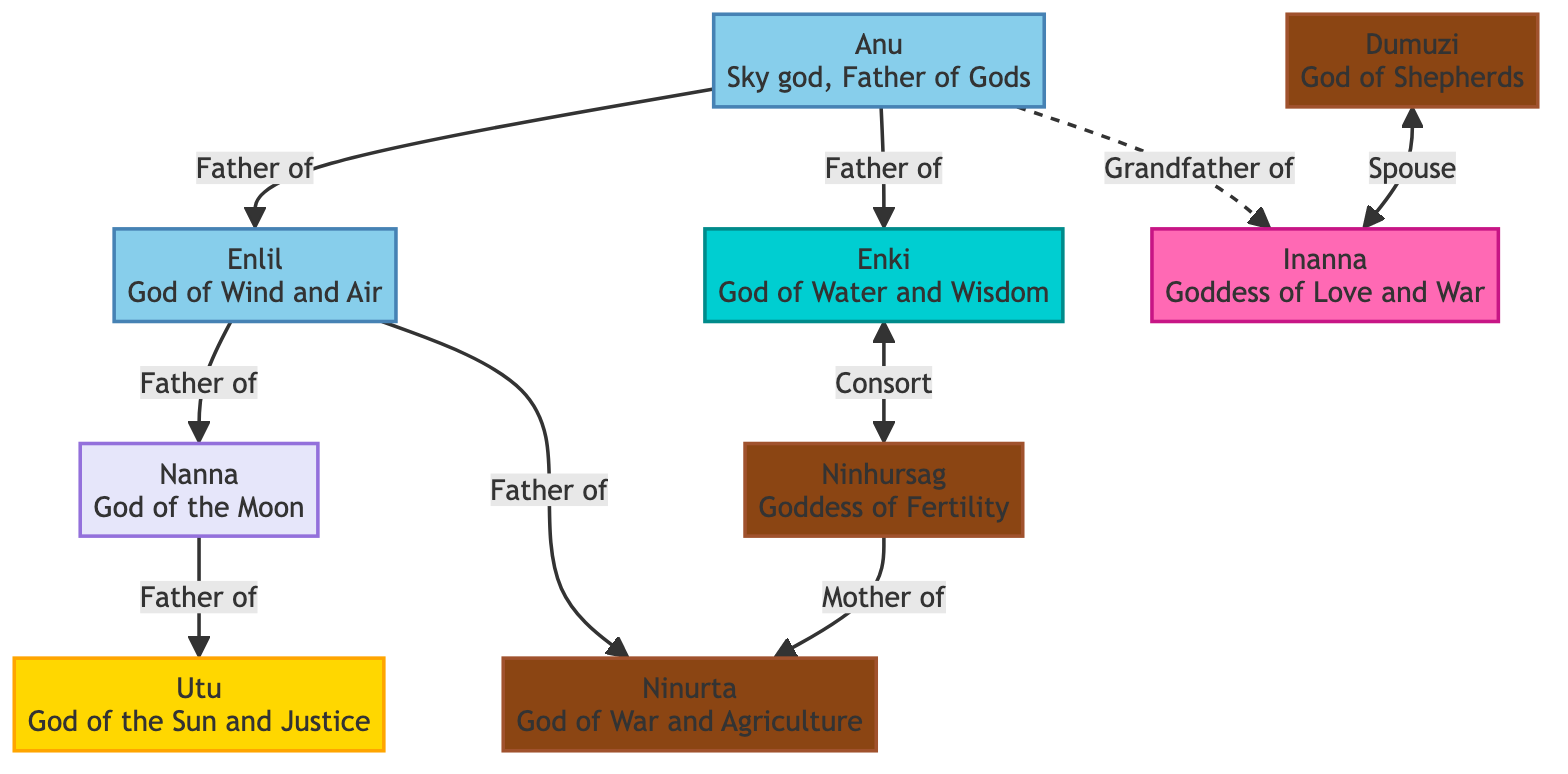What is the primary role of Anu in the diagram? Anu is depicted as the Sky god and the Father of Gods, indicating his primary role is to oversee the pantheon and parent the major deities.
Answer: Father of Gods Which two deities are known to have a consort relationship? Enki and Ninhursag are shown with a bidirectional relationship indicating they are consorts, meaning they are partners in some capacity.
Answer: Enki and Ninhursag How many deities are connected to Enlil as a father? Enlil has arrows leading to two deities, which are Nanna and Ninurta, indicating he is their father, hence the count is 2.
Answer: 2 Who is the mother of Ninurta? The diagram shows a direct link from Ninhursag to Ninurta labeled "Mother of", indicating she is his mother.
Answer: Ninhursag What is the relationship between Dumuzi and Inanna? The diagram shows a bidirectional link between Dumuzi and Inanna labeled "Spouse", indicating they are married or partners.
Answer: Spouse What color represents the water god in the diagram? The diagram uses a distinct color (turquoise) for the water god, which in this context is Enki. This allows for easy identification of deities by their categories.
Answer: Turquoise Which god is directly connected to the moon god? The moon god Nanna has a direct relationship leading to Utu, which identifies Utu as the deity directly connected to Nanna.
Answer: Utu How are deities categorized in the diagram? The diagram categorizes deities using colors representing different themes such as sky, water, earth, and love, allowing viewers to understand their domains quickly.
Answer: By color categories What relationship does Anu have with Inanna? The diagram shows Anu's relationship with Inanna as a dashed line indicating "Grandfather of", which signifies a generational link.
Answer: Grandfather 